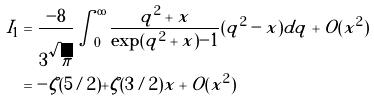Convert formula to latex. <formula><loc_0><loc_0><loc_500><loc_500>I _ { 1 } & = { \frac { - 8 } { 3 \sqrt { \pi } } } \int _ { 0 } ^ { \infty } { \frac { q ^ { 2 } + x } { \exp ( q ^ { 2 } + x ) - 1 } } ( q ^ { 2 } - x ) d q + O ( x ^ { 2 } ) \\ & = - \zeta ( 5 / 2 ) + \zeta ( 3 / 2 ) x + O ( x ^ { 2 } )</formula> 